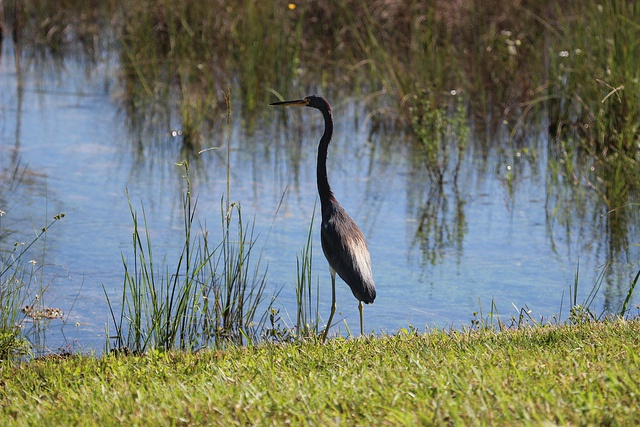Describe the objects in this image and their specific colors. I can see a bird in gray, black, and darkgray tones in this image. 